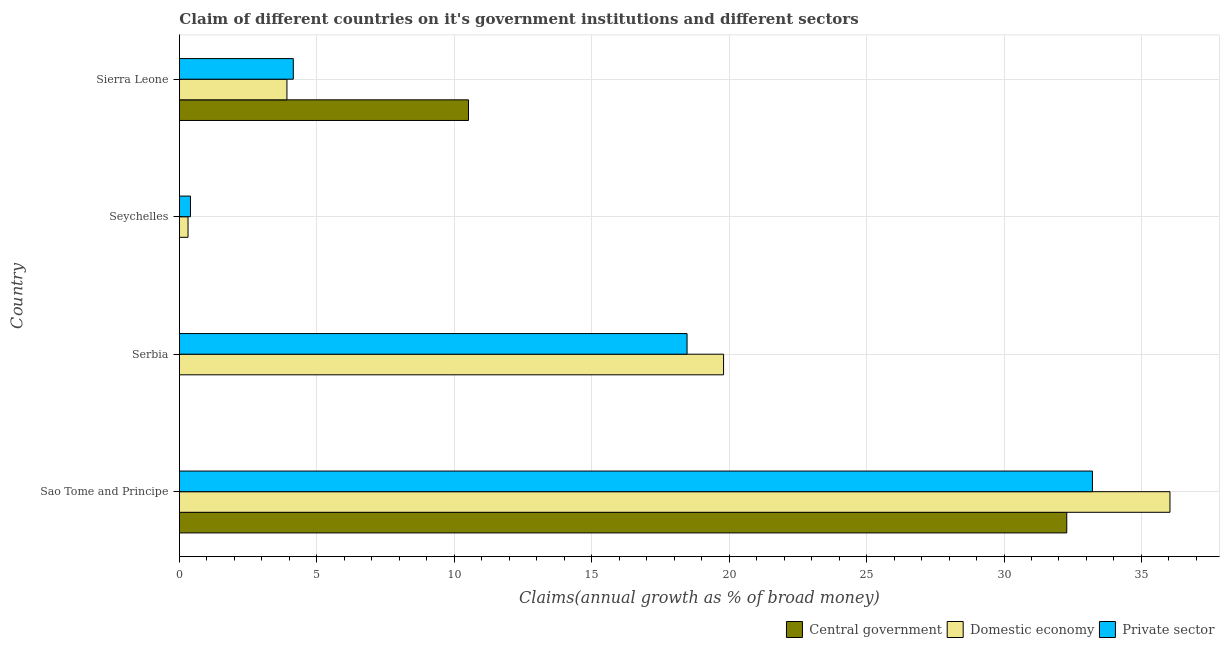How many groups of bars are there?
Give a very brief answer. 4. Are the number of bars per tick equal to the number of legend labels?
Keep it short and to the point. No. How many bars are there on the 4th tick from the top?
Keep it short and to the point. 3. What is the label of the 2nd group of bars from the top?
Offer a very short reply. Seychelles. In how many cases, is the number of bars for a given country not equal to the number of legend labels?
Your answer should be very brief. 2. What is the percentage of claim on the domestic economy in Sao Tome and Principe?
Offer a very short reply. 36.04. Across all countries, what is the maximum percentage of claim on the domestic economy?
Provide a succinct answer. 36.04. Across all countries, what is the minimum percentage of claim on the domestic economy?
Offer a very short reply. 0.31. In which country was the percentage of claim on the private sector maximum?
Your answer should be compact. Sao Tome and Principe. What is the total percentage of claim on the domestic economy in the graph?
Provide a succinct answer. 60.06. What is the difference between the percentage of claim on the private sector in Seychelles and that in Sierra Leone?
Your response must be concise. -3.74. What is the difference between the percentage of claim on the domestic economy in Sao Tome and Principe and the percentage of claim on the private sector in Serbia?
Give a very brief answer. 17.57. What is the average percentage of claim on the domestic economy per country?
Make the answer very short. 15.02. What is the difference between the percentage of claim on the central government and percentage of claim on the private sector in Sao Tome and Principe?
Your answer should be compact. -0.93. In how many countries, is the percentage of claim on the central government greater than 23 %?
Keep it short and to the point. 1. What is the ratio of the percentage of claim on the private sector in Serbia to that in Seychelles?
Your answer should be very brief. 45.88. What is the difference between the highest and the second highest percentage of claim on the domestic economy?
Your answer should be compact. 16.24. What is the difference between the highest and the lowest percentage of claim on the central government?
Provide a short and direct response. 32.28. Is the sum of the percentage of claim on the domestic economy in Sao Tome and Principe and Sierra Leone greater than the maximum percentage of claim on the private sector across all countries?
Give a very brief answer. Yes. Is it the case that in every country, the sum of the percentage of claim on the central government and percentage of claim on the domestic economy is greater than the percentage of claim on the private sector?
Your response must be concise. No. Are all the bars in the graph horizontal?
Keep it short and to the point. Yes. How many countries are there in the graph?
Provide a succinct answer. 4. Are the values on the major ticks of X-axis written in scientific E-notation?
Offer a terse response. No. Does the graph contain any zero values?
Give a very brief answer. Yes. Where does the legend appear in the graph?
Your response must be concise. Bottom right. How many legend labels are there?
Offer a very short reply. 3. How are the legend labels stacked?
Your response must be concise. Horizontal. What is the title of the graph?
Keep it short and to the point. Claim of different countries on it's government institutions and different sectors. Does "Ages 65 and above" appear as one of the legend labels in the graph?
Your answer should be compact. No. What is the label or title of the X-axis?
Give a very brief answer. Claims(annual growth as % of broad money). What is the label or title of the Y-axis?
Keep it short and to the point. Country. What is the Claims(annual growth as % of broad money) in Central government in Sao Tome and Principe?
Offer a very short reply. 32.28. What is the Claims(annual growth as % of broad money) of Domestic economy in Sao Tome and Principe?
Offer a very short reply. 36.04. What is the Claims(annual growth as % of broad money) of Private sector in Sao Tome and Principe?
Ensure brevity in your answer.  33.22. What is the Claims(annual growth as % of broad money) of Central government in Serbia?
Give a very brief answer. 0. What is the Claims(annual growth as % of broad money) in Domestic economy in Serbia?
Offer a very short reply. 19.8. What is the Claims(annual growth as % of broad money) in Private sector in Serbia?
Your answer should be compact. 18.47. What is the Claims(annual growth as % of broad money) of Domestic economy in Seychelles?
Your answer should be compact. 0.31. What is the Claims(annual growth as % of broad money) in Private sector in Seychelles?
Offer a very short reply. 0.4. What is the Claims(annual growth as % of broad money) in Central government in Sierra Leone?
Your answer should be very brief. 10.52. What is the Claims(annual growth as % of broad money) in Domestic economy in Sierra Leone?
Your answer should be very brief. 3.91. What is the Claims(annual growth as % of broad money) of Private sector in Sierra Leone?
Give a very brief answer. 4.14. Across all countries, what is the maximum Claims(annual growth as % of broad money) of Central government?
Offer a terse response. 32.28. Across all countries, what is the maximum Claims(annual growth as % of broad money) of Domestic economy?
Keep it short and to the point. 36.04. Across all countries, what is the maximum Claims(annual growth as % of broad money) in Private sector?
Your answer should be very brief. 33.22. Across all countries, what is the minimum Claims(annual growth as % of broad money) in Domestic economy?
Provide a short and direct response. 0.31. Across all countries, what is the minimum Claims(annual growth as % of broad money) of Private sector?
Ensure brevity in your answer.  0.4. What is the total Claims(annual growth as % of broad money) of Central government in the graph?
Make the answer very short. 42.8. What is the total Claims(annual growth as % of broad money) in Domestic economy in the graph?
Your response must be concise. 60.06. What is the total Claims(annual growth as % of broad money) in Private sector in the graph?
Keep it short and to the point. 56.23. What is the difference between the Claims(annual growth as % of broad money) in Domestic economy in Sao Tome and Principe and that in Serbia?
Your answer should be compact. 16.24. What is the difference between the Claims(annual growth as % of broad money) in Private sector in Sao Tome and Principe and that in Serbia?
Provide a short and direct response. 14.75. What is the difference between the Claims(annual growth as % of broad money) in Domestic economy in Sao Tome and Principe and that in Seychelles?
Your answer should be very brief. 35.72. What is the difference between the Claims(annual growth as % of broad money) in Private sector in Sao Tome and Principe and that in Seychelles?
Your response must be concise. 32.81. What is the difference between the Claims(annual growth as % of broad money) in Central government in Sao Tome and Principe and that in Sierra Leone?
Offer a terse response. 21.77. What is the difference between the Claims(annual growth as % of broad money) in Domestic economy in Sao Tome and Principe and that in Sierra Leone?
Keep it short and to the point. 32.13. What is the difference between the Claims(annual growth as % of broad money) of Private sector in Sao Tome and Principe and that in Sierra Leone?
Provide a short and direct response. 29.07. What is the difference between the Claims(annual growth as % of broad money) in Domestic economy in Serbia and that in Seychelles?
Your answer should be compact. 19.48. What is the difference between the Claims(annual growth as % of broad money) in Private sector in Serbia and that in Seychelles?
Offer a very short reply. 18.07. What is the difference between the Claims(annual growth as % of broad money) of Domestic economy in Serbia and that in Sierra Leone?
Give a very brief answer. 15.89. What is the difference between the Claims(annual growth as % of broad money) in Private sector in Serbia and that in Sierra Leone?
Provide a succinct answer. 14.33. What is the difference between the Claims(annual growth as % of broad money) of Domestic economy in Seychelles and that in Sierra Leone?
Your answer should be compact. -3.6. What is the difference between the Claims(annual growth as % of broad money) in Private sector in Seychelles and that in Sierra Leone?
Your answer should be compact. -3.74. What is the difference between the Claims(annual growth as % of broad money) in Central government in Sao Tome and Principe and the Claims(annual growth as % of broad money) in Domestic economy in Serbia?
Give a very brief answer. 12.49. What is the difference between the Claims(annual growth as % of broad money) in Central government in Sao Tome and Principe and the Claims(annual growth as % of broad money) in Private sector in Serbia?
Provide a short and direct response. 13.81. What is the difference between the Claims(annual growth as % of broad money) of Domestic economy in Sao Tome and Principe and the Claims(annual growth as % of broad money) of Private sector in Serbia?
Your answer should be very brief. 17.57. What is the difference between the Claims(annual growth as % of broad money) in Central government in Sao Tome and Principe and the Claims(annual growth as % of broad money) in Domestic economy in Seychelles?
Your answer should be compact. 31.97. What is the difference between the Claims(annual growth as % of broad money) in Central government in Sao Tome and Principe and the Claims(annual growth as % of broad money) in Private sector in Seychelles?
Provide a succinct answer. 31.88. What is the difference between the Claims(annual growth as % of broad money) of Domestic economy in Sao Tome and Principe and the Claims(annual growth as % of broad money) of Private sector in Seychelles?
Your answer should be compact. 35.64. What is the difference between the Claims(annual growth as % of broad money) of Central government in Sao Tome and Principe and the Claims(annual growth as % of broad money) of Domestic economy in Sierra Leone?
Keep it short and to the point. 28.37. What is the difference between the Claims(annual growth as % of broad money) of Central government in Sao Tome and Principe and the Claims(annual growth as % of broad money) of Private sector in Sierra Leone?
Your response must be concise. 28.14. What is the difference between the Claims(annual growth as % of broad money) in Domestic economy in Sao Tome and Principe and the Claims(annual growth as % of broad money) in Private sector in Sierra Leone?
Your answer should be very brief. 31.89. What is the difference between the Claims(annual growth as % of broad money) of Domestic economy in Serbia and the Claims(annual growth as % of broad money) of Private sector in Seychelles?
Your answer should be very brief. 19.39. What is the difference between the Claims(annual growth as % of broad money) in Domestic economy in Serbia and the Claims(annual growth as % of broad money) in Private sector in Sierra Leone?
Your response must be concise. 15.65. What is the difference between the Claims(annual growth as % of broad money) of Domestic economy in Seychelles and the Claims(annual growth as % of broad money) of Private sector in Sierra Leone?
Your answer should be very brief. -3.83. What is the average Claims(annual growth as % of broad money) in Central government per country?
Make the answer very short. 10.7. What is the average Claims(annual growth as % of broad money) of Domestic economy per country?
Make the answer very short. 15.02. What is the average Claims(annual growth as % of broad money) in Private sector per country?
Give a very brief answer. 14.06. What is the difference between the Claims(annual growth as % of broad money) in Central government and Claims(annual growth as % of broad money) in Domestic economy in Sao Tome and Principe?
Ensure brevity in your answer.  -3.75. What is the difference between the Claims(annual growth as % of broad money) in Central government and Claims(annual growth as % of broad money) in Private sector in Sao Tome and Principe?
Your answer should be compact. -0.93. What is the difference between the Claims(annual growth as % of broad money) of Domestic economy and Claims(annual growth as % of broad money) of Private sector in Sao Tome and Principe?
Make the answer very short. 2.82. What is the difference between the Claims(annual growth as % of broad money) in Domestic economy and Claims(annual growth as % of broad money) in Private sector in Serbia?
Make the answer very short. 1.33. What is the difference between the Claims(annual growth as % of broad money) in Domestic economy and Claims(annual growth as % of broad money) in Private sector in Seychelles?
Keep it short and to the point. -0.09. What is the difference between the Claims(annual growth as % of broad money) of Central government and Claims(annual growth as % of broad money) of Domestic economy in Sierra Leone?
Offer a very short reply. 6.6. What is the difference between the Claims(annual growth as % of broad money) of Central government and Claims(annual growth as % of broad money) of Private sector in Sierra Leone?
Your answer should be very brief. 6.37. What is the difference between the Claims(annual growth as % of broad money) of Domestic economy and Claims(annual growth as % of broad money) of Private sector in Sierra Leone?
Your response must be concise. -0.23. What is the ratio of the Claims(annual growth as % of broad money) of Domestic economy in Sao Tome and Principe to that in Serbia?
Make the answer very short. 1.82. What is the ratio of the Claims(annual growth as % of broad money) of Private sector in Sao Tome and Principe to that in Serbia?
Offer a very short reply. 1.8. What is the ratio of the Claims(annual growth as % of broad money) of Domestic economy in Sao Tome and Principe to that in Seychelles?
Your answer should be compact. 114.94. What is the ratio of the Claims(annual growth as % of broad money) of Private sector in Sao Tome and Principe to that in Seychelles?
Make the answer very short. 82.51. What is the ratio of the Claims(annual growth as % of broad money) of Central government in Sao Tome and Principe to that in Sierra Leone?
Your response must be concise. 3.07. What is the ratio of the Claims(annual growth as % of broad money) of Domestic economy in Sao Tome and Principe to that in Sierra Leone?
Make the answer very short. 9.21. What is the ratio of the Claims(annual growth as % of broad money) in Private sector in Sao Tome and Principe to that in Sierra Leone?
Provide a short and direct response. 8.02. What is the ratio of the Claims(annual growth as % of broad money) of Domestic economy in Serbia to that in Seychelles?
Your answer should be compact. 63.14. What is the ratio of the Claims(annual growth as % of broad money) of Private sector in Serbia to that in Seychelles?
Your answer should be compact. 45.88. What is the ratio of the Claims(annual growth as % of broad money) of Domestic economy in Serbia to that in Sierra Leone?
Give a very brief answer. 5.06. What is the ratio of the Claims(annual growth as % of broad money) in Private sector in Serbia to that in Sierra Leone?
Your response must be concise. 4.46. What is the ratio of the Claims(annual growth as % of broad money) in Domestic economy in Seychelles to that in Sierra Leone?
Your answer should be very brief. 0.08. What is the ratio of the Claims(annual growth as % of broad money) of Private sector in Seychelles to that in Sierra Leone?
Your answer should be compact. 0.1. What is the difference between the highest and the second highest Claims(annual growth as % of broad money) in Domestic economy?
Provide a succinct answer. 16.24. What is the difference between the highest and the second highest Claims(annual growth as % of broad money) of Private sector?
Make the answer very short. 14.75. What is the difference between the highest and the lowest Claims(annual growth as % of broad money) of Central government?
Give a very brief answer. 32.28. What is the difference between the highest and the lowest Claims(annual growth as % of broad money) of Domestic economy?
Offer a terse response. 35.72. What is the difference between the highest and the lowest Claims(annual growth as % of broad money) in Private sector?
Provide a short and direct response. 32.81. 